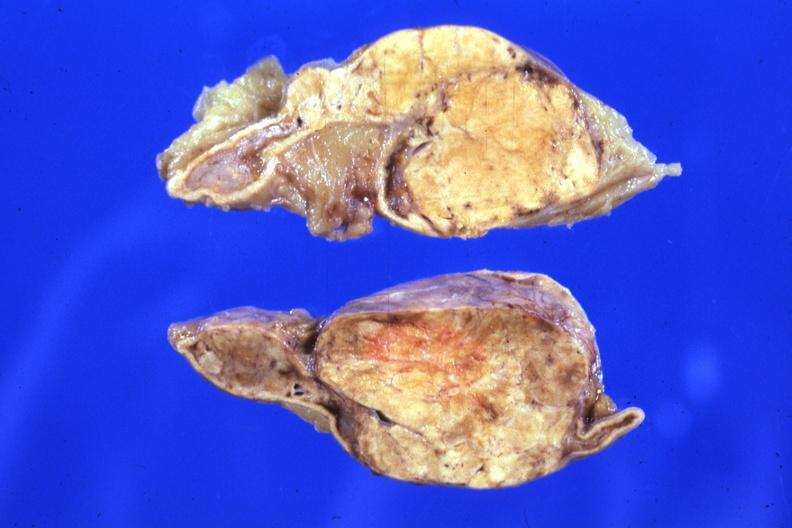s fixed tissue sectioned gland rather large lesion?
Answer the question using a single word or phrase. Yes 